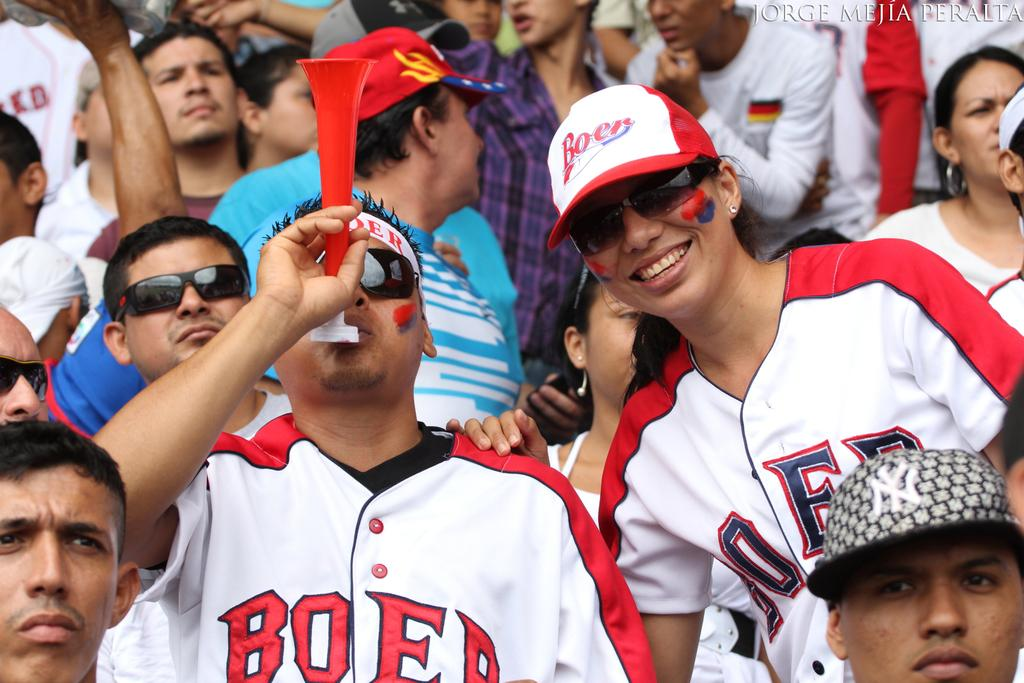<image>
Give a short and clear explanation of the subsequent image. A male and female fan wearing a Boer Jersey 